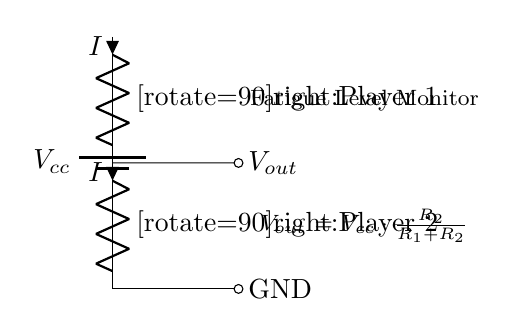What are the components used in this circuit? The circuit includes a battery, two resistors, and nodes for output and ground.
Answer: battery, resistors What is the total resistance in the circuit? The total resistance in a series circuit is the sum of the individual resistances, which are R1 and R2.
Answer: R1 + R2 What does the output voltage depend on? The output voltage depends on the ratio of R2 to the total resistance (R1 + R2) multiplied by the supply voltage (Vcc).
Answer: R2 / (R1 + R2) * Vcc How many players' fatigue levels can be monitored with this circuit? The circuit design specifies monitoring for two players, as indicated by the labels.
Answer: Two players If R1 is twice the value of R2, what is the voltage output expression? If R1 = 2R2, then Vout can be expressed as Vcc times the ratio of R2 to the sum of R1 and R2, simplifying to Vcc divided by 3.
Answer: Vcc / 3 What denotes the current flow in this circuit? The arrows next to the resistors labeled I indicate the direction of the current flow.
Answer: I What is the purpose of this voltage divider circuit? The main purpose is to monitor and assess the fatigue level of two players by measuring the output voltage, which reflects their combined resistance.
Answer: Monitor fatigue levels 